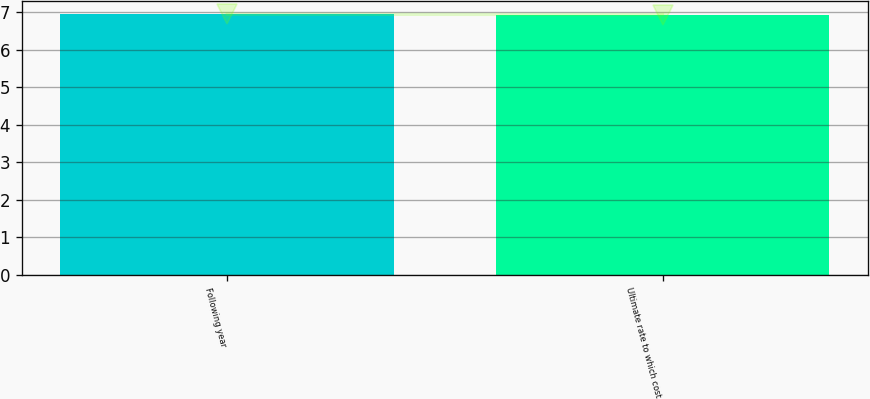<chart> <loc_0><loc_0><loc_500><loc_500><bar_chart><fcel>Following year<fcel>Ultimate rate to which cost<nl><fcel>6.94<fcel>6.93<nl></chart> 